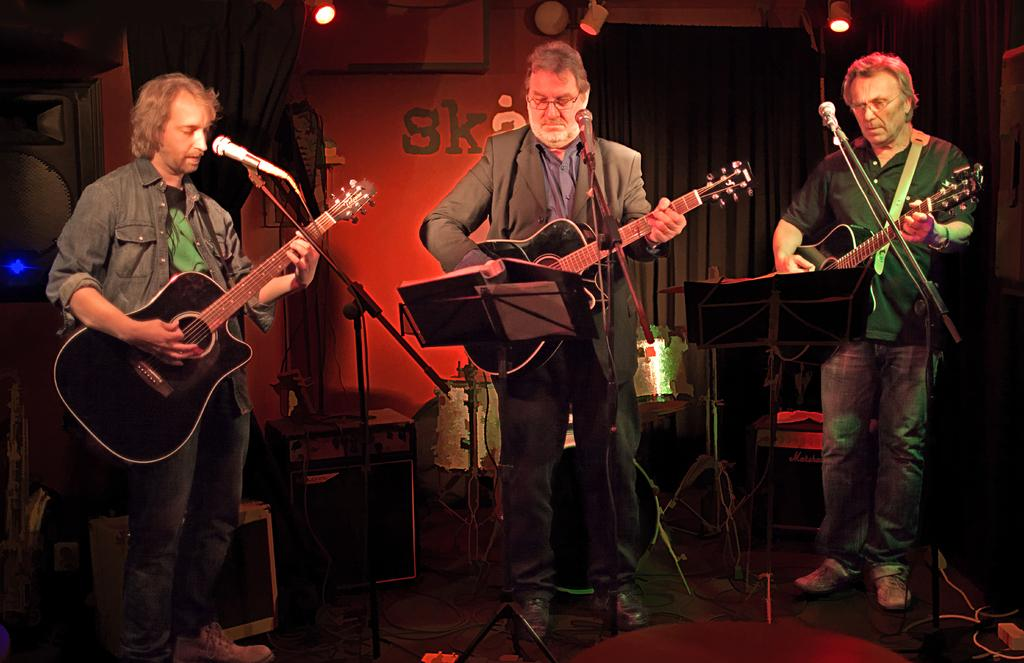What type of window treatment is visible in the image? There are curtains in the image. What is happening on stage in the image? There are three people standing on stage, and they are holding guitars and singing into a microphone. Can you tell me what time it is according to the clock in the image? There is no clock present in the image. What type of honey is being used by the people on stage in the image? There is no honey present in the image; the people are holding guitars and singing into a microphones into a microphone. 